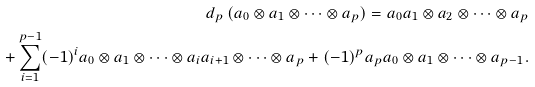<formula> <loc_0><loc_0><loc_500><loc_500>d _ { p } \, ( a _ { 0 } \otimes a _ { 1 } \otimes \dots \otimes a _ { p } ) = a _ { 0 } a _ { 1 } \otimes a _ { 2 } \otimes \dots \otimes a _ { p } \\ + \sum _ { i = 1 } ^ { p - 1 } ( - 1 ) ^ { i } a _ { 0 } \otimes a _ { 1 } \otimes \dots \otimes a _ { i } a _ { i + 1 } \otimes \dots \otimes a _ { p } + ( - 1 ) ^ { p } a _ { p } a _ { 0 } \otimes a _ { 1 } \otimes \dots \otimes a _ { p - 1 } .</formula> 